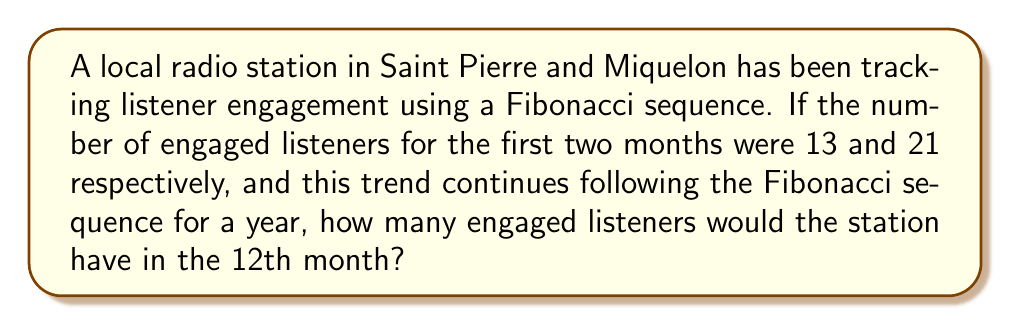Show me your answer to this math problem. Let's approach this step-by-step:

1) First, recall that in a Fibonacci sequence, each number is the sum of the two preceding ones. The sequence starts with:

   $F_n = F_{n-1} + F_{n-2}$

2) We're given the first two numbers of our sequence:
   $F_1 = 13$
   $F_2 = 21$

3) Let's calculate the subsequent numbers:
   $F_3 = F_2 + F_1 = 21 + 13 = 34$
   $F_4 = F_3 + F_2 = 34 + 21 = 55$
   $F_5 = F_4 + F_3 = 55 + 34 = 89$
   $F_6 = F_5 + F_4 = 89 + 55 = 144$
   $F_7 = F_6 + F_5 = 144 + 89 = 233$
   $F_8 = F_7 + F_6 = 233 + 144 = 377$
   $F_9 = F_8 + F_7 = 377 + 233 = 610$
   $F_{10} = F_9 + F_8 = 610 + 377 = 987$
   $F_{11} = F_{10} + F_9 = 987 + 610 = 1597$
   $F_{12} = F_{11} + F_{10} = 1597 + 987 = 2584$

4) Therefore, in the 12th month, the number of engaged listeners would be 2584.
Answer: 2584 